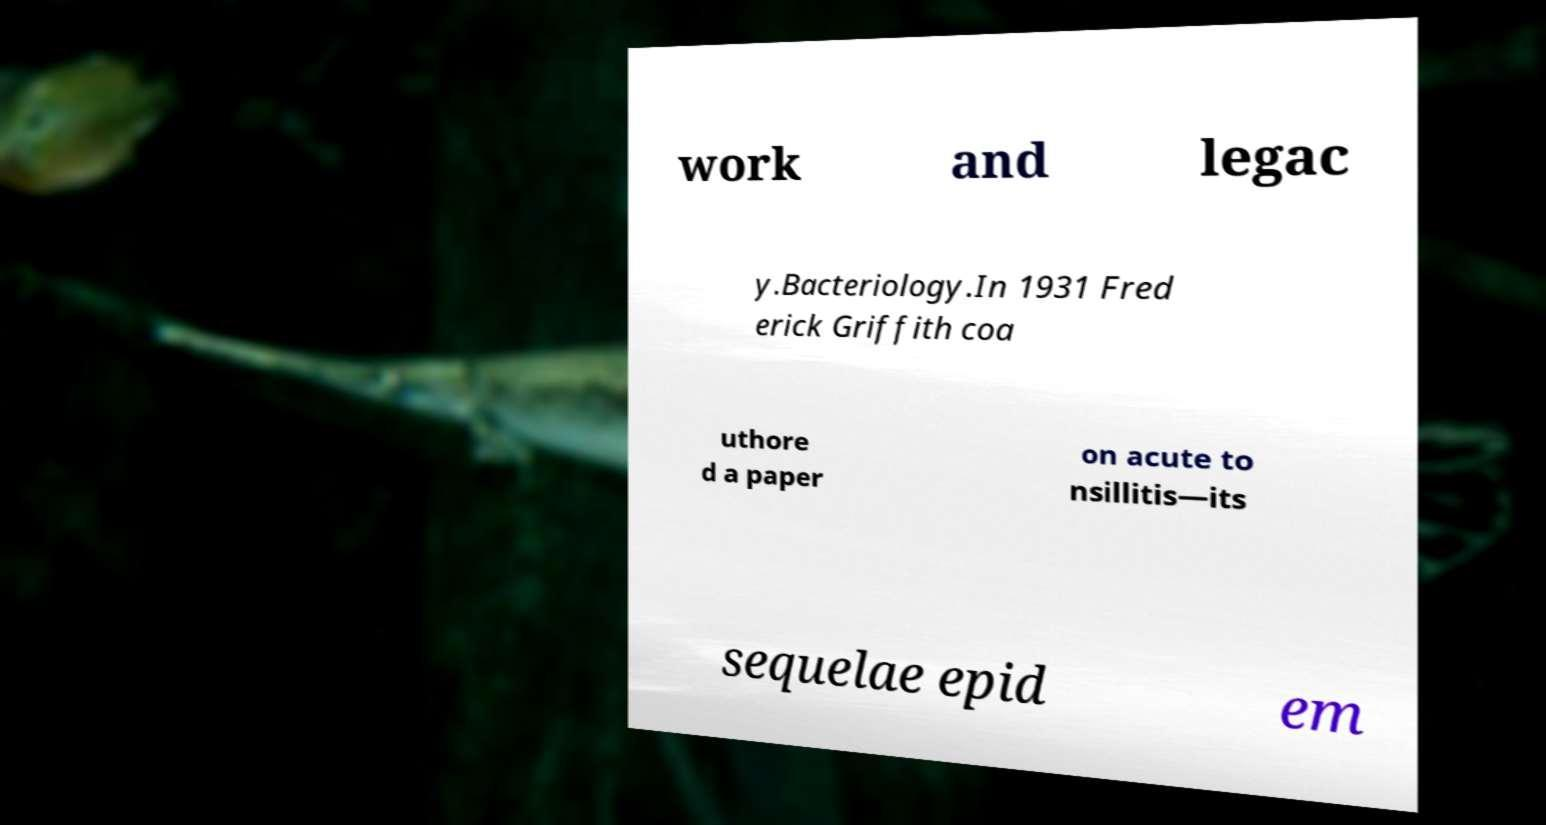Please identify and transcribe the text found in this image. work and legac y.Bacteriology.In 1931 Fred erick Griffith coa uthore d a paper on acute to nsillitis—its sequelae epid em 